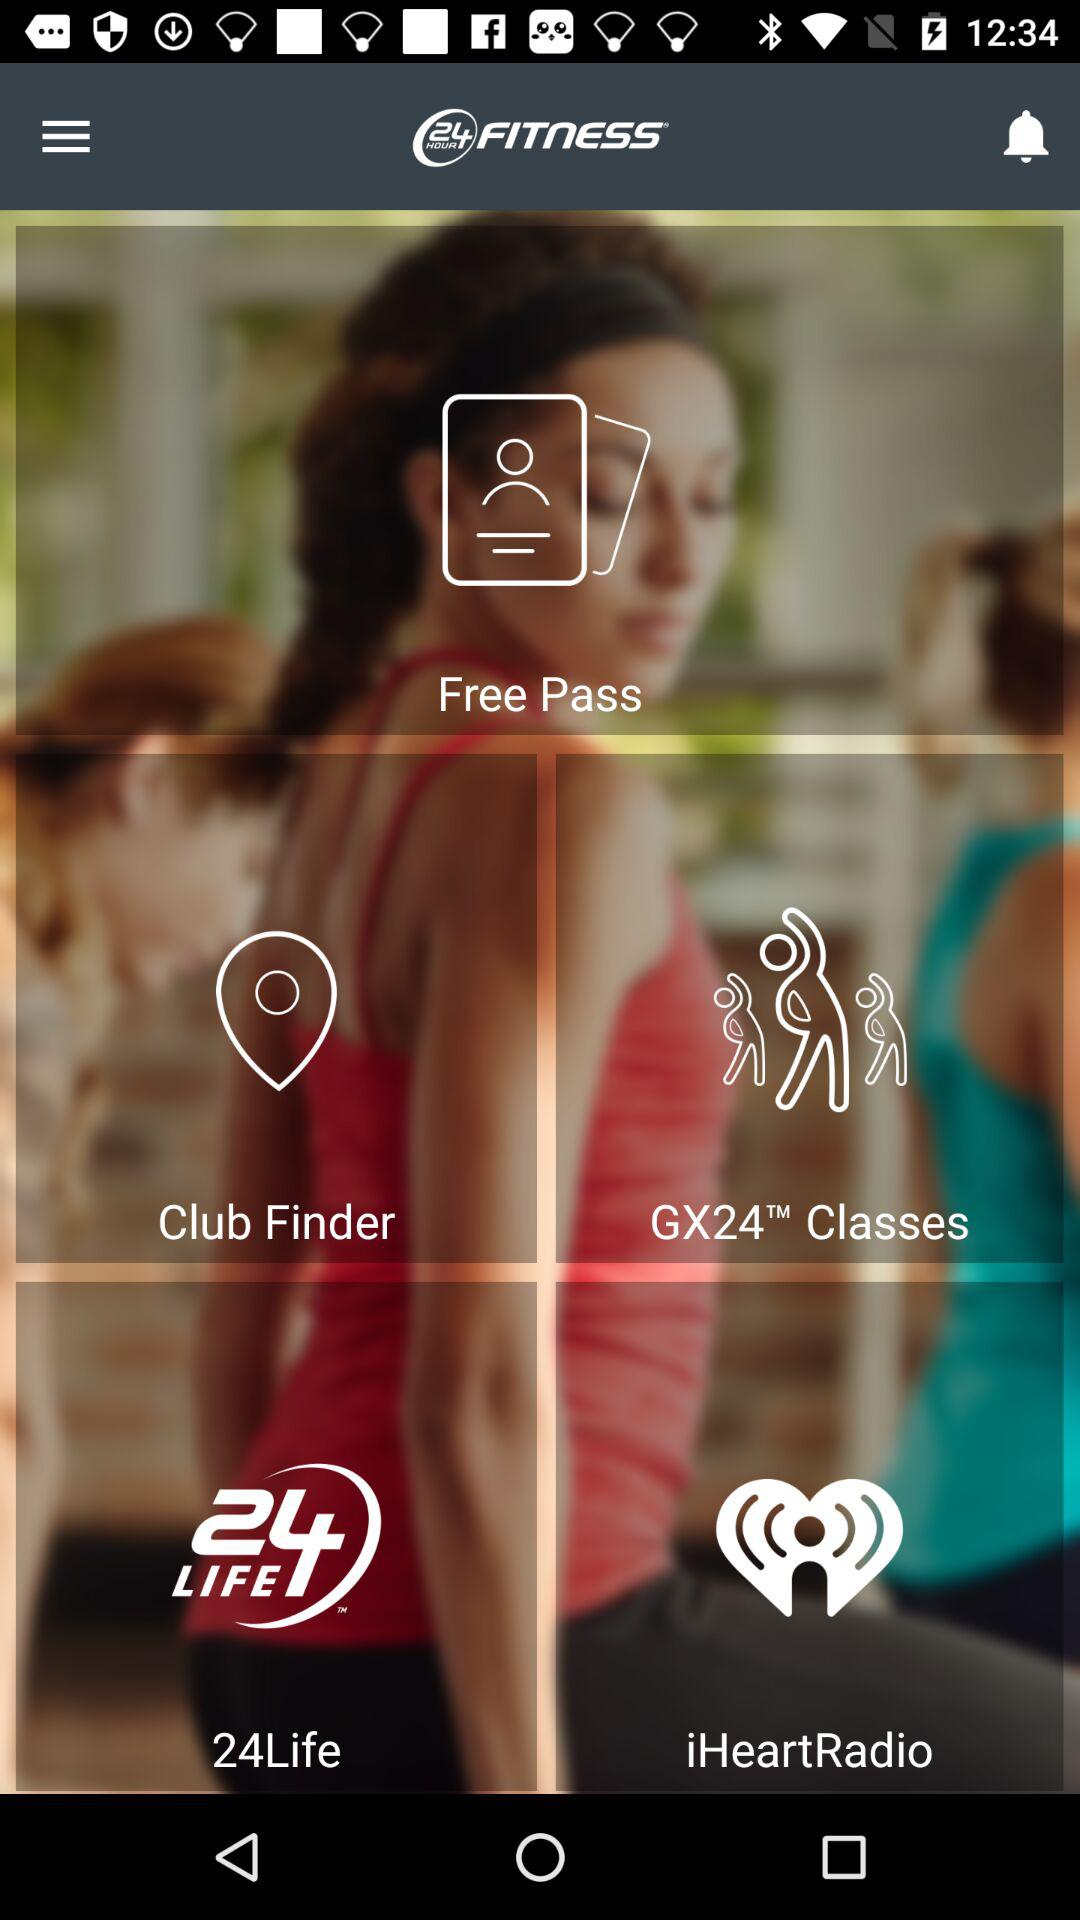Where is the nearest 24 Hour Fitness location?
When the provided information is insufficient, respond with <no answer>. <no answer> 